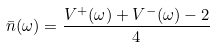Convert formula to latex. <formula><loc_0><loc_0><loc_500><loc_500>\bar { n } ( \omega ) = \frac { V ^ { + } ( \omega ) + V ^ { - } ( \omega ) - 2 } { 4 }</formula> 